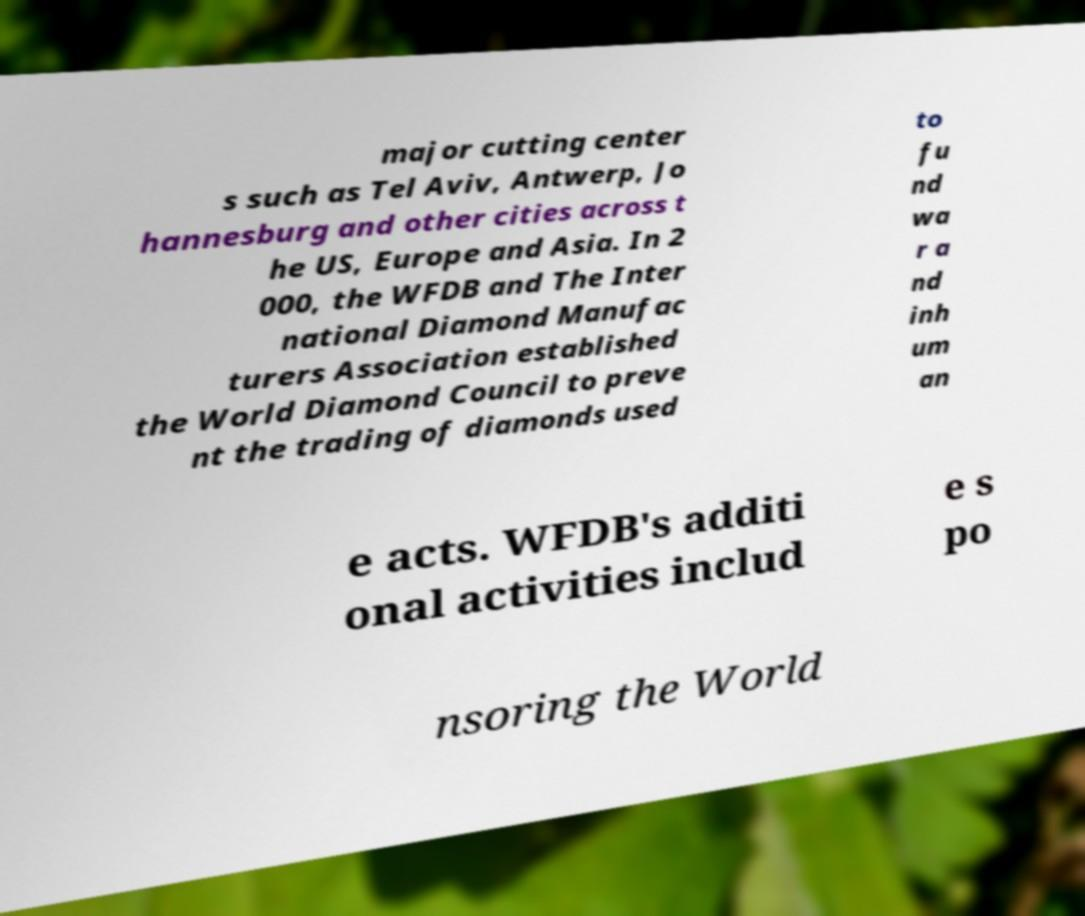Could you extract and type out the text from this image? major cutting center s such as Tel Aviv, Antwerp, Jo hannesburg and other cities across t he US, Europe and Asia. In 2 000, the WFDB and The Inter national Diamond Manufac turers Association established the World Diamond Council to preve nt the trading of diamonds used to fu nd wa r a nd inh um an e acts. WFDB's additi onal activities includ e s po nsoring the World 